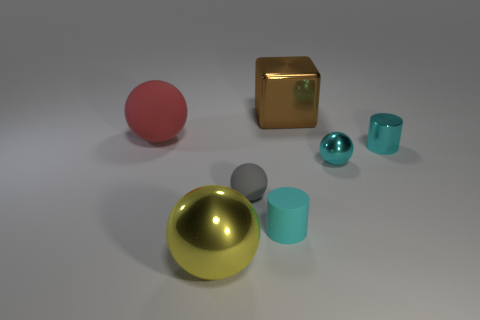Subtract all green spheres. Subtract all yellow blocks. How many spheres are left? 4 Add 3 small metallic balls. How many objects exist? 10 Subtract all spheres. How many objects are left? 3 Add 2 large matte spheres. How many large matte spheres are left? 3 Add 4 large red blocks. How many large red blocks exist? 4 Subtract 0 green cylinders. How many objects are left? 7 Subtract all tiny spheres. Subtract all large matte objects. How many objects are left? 4 